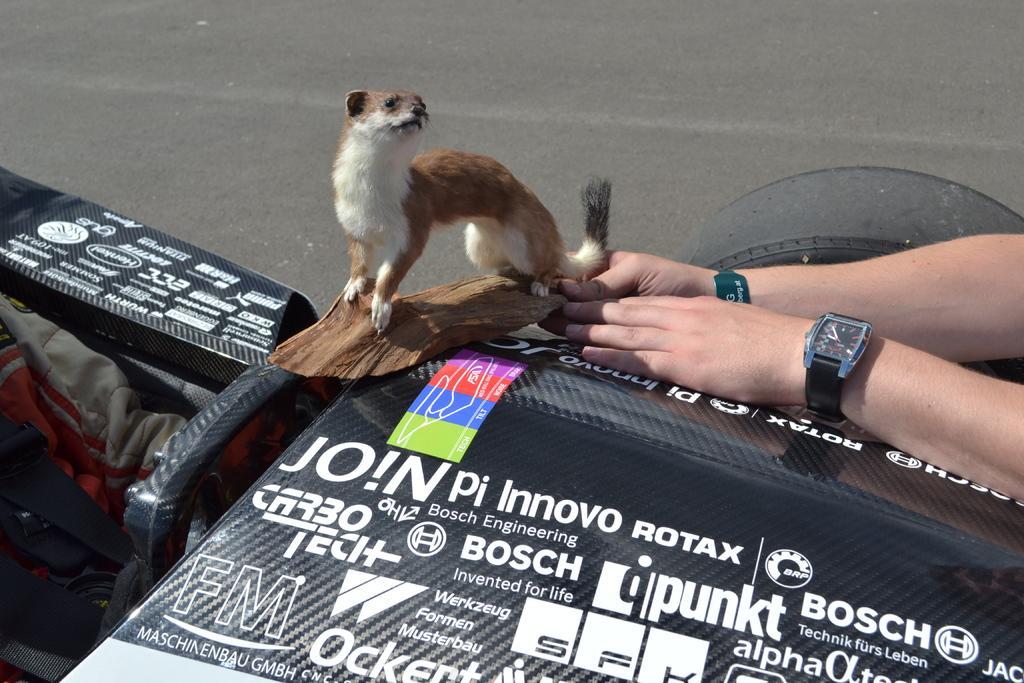In one or two sentences, can you explain what this image depicts? In the image we can see an animal, on the piece of wood block. This is a wristwatch, tires and a road. We can even see human hands and this is a text. 